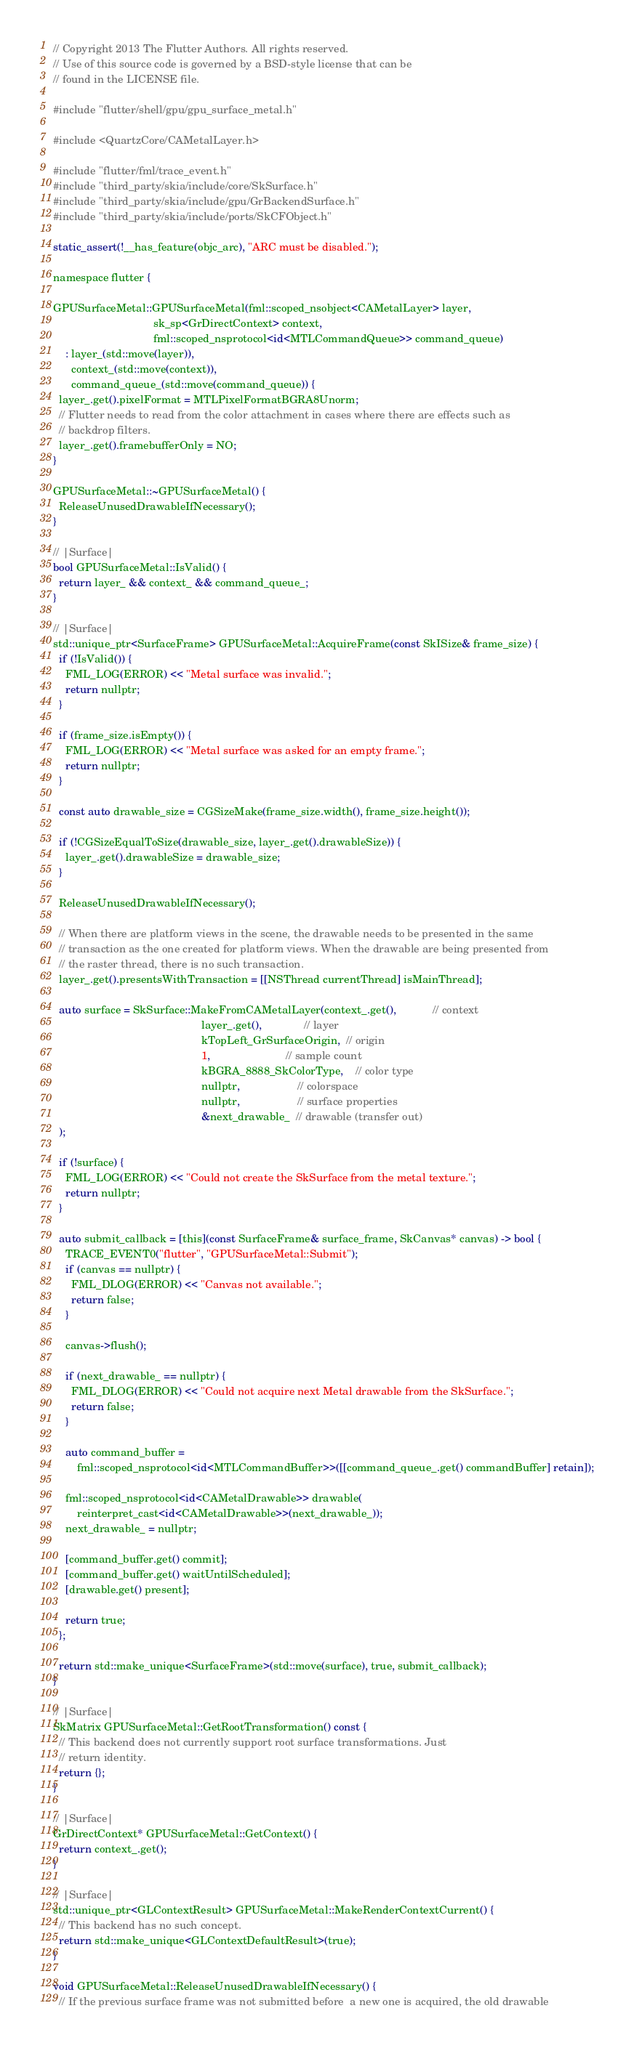Convert code to text. <code><loc_0><loc_0><loc_500><loc_500><_ObjectiveC_>// Copyright 2013 The Flutter Authors. All rights reserved.
// Use of this source code is governed by a BSD-style license that can be
// found in the LICENSE file.

#include "flutter/shell/gpu/gpu_surface_metal.h"

#include <QuartzCore/CAMetalLayer.h>

#include "flutter/fml/trace_event.h"
#include "third_party/skia/include/core/SkSurface.h"
#include "third_party/skia/include/gpu/GrBackendSurface.h"
#include "third_party/skia/include/ports/SkCFObject.h"

static_assert(!__has_feature(objc_arc), "ARC must be disabled.");

namespace flutter {

GPUSurfaceMetal::GPUSurfaceMetal(fml::scoped_nsobject<CAMetalLayer> layer,
                                 sk_sp<GrDirectContext> context,
                                 fml::scoped_nsprotocol<id<MTLCommandQueue>> command_queue)
    : layer_(std::move(layer)),
      context_(std::move(context)),
      command_queue_(std::move(command_queue)) {
  layer_.get().pixelFormat = MTLPixelFormatBGRA8Unorm;
  // Flutter needs to read from the color attachment in cases where there are effects such as
  // backdrop filters.
  layer_.get().framebufferOnly = NO;
}

GPUSurfaceMetal::~GPUSurfaceMetal() {
  ReleaseUnusedDrawableIfNecessary();
}

// |Surface|
bool GPUSurfaceMetal::IsValid() {
  return layer_ && context_ && command_queue_;
}

// |Surface|
std::unique_ptr<SurfaceFrame> GPUSurfaceMetal::AcquireFrame(const SkISize& frame_size) {
  if (!IsValid()) {
    FML_LOG(ERROR) << "Metal surface was invalid.";
    return nullptr;
  }

  if (frame_size.isEmpty()) {
    FML_LOG(ERROR) << "Metal surface was asked for an empty frame.";
    return nullptr;
  }

  const auto drawable_size = CGSizeMake(frame_size.width(), frame_size.height());

  if (!CGSizeEqualToSize(drawable_size, layer_.get().drawableSize)) {
    layer_.get().drawableSize = drawable_size;
  }

  ReleaseUnusedDrawableIfNecessary();

  // When there are platform views in the scene, the drawable needs to be presented in the same
  // transaction as the one created for platform views. When the drawable are being presented from
  // the raster thread, there is no such transaction.
  layer_.get().presentsWithTransaction = [[NSThread currentThread] isMainThread];

  auto surface = SkSurface::MakeFromCAMetalLayer(context_.get(),            // context
                                                 layer_.get(),              // layer
                                                 kTopLeft_GrSurfaceOrigin,  // origin
                                                 1,                         // sample count
                                                 kBGRA_8888_SkColorType,    // color type
                                                 nullptr,                   // colorspace
                                                 nullptr,                   // surface properties
                                                 &next_drawable_  // drawable (transfer out)
  );

  if (!surface) {
    FML_LOG(ERROR) << "Could not create the SkSurface from the metal texture.";
    return nullptr;
  }

  auto submit_callback = [this](const SurfaceFrame& surface_frame, SkCanvas* canvas) -> bool {
    TRACE_EVENT0("flutter", "GPUSurfaceMetal::Submit");
    if (canvas == nullptr) {
      FML_DLOG(ERROR) << "Canvas not available.";
      return false;
    }

    canvas->flush();

    if (next_drawable_ == nullptr) {
      FML_DLOG(ERROR) << "Could not acquire next Metal drawable from the SkSurface.";
      return false;
    }

    auto command_buffer =
        fml::scoped_nsprotocol<id<MTLCommandBuffer>>([[command_queue_.get() commandBuffer] retain]);

    fml::scoped_nsprotocol<id<CAMetalDrawable>> drawable(
        reinterpret_cast<id<CAMetalDrawable>>(next_drawable_));
    next_drawable_ = nullptr;

    [command_buffer.get() commit];
    [command_buffer.get() waitUntilScheduled];
    [drawable.get() present];

    return true;
  };

  return std::make_unique<SurfaceFrame>(std::move(surface), true, submit_callback);
}

// |Surface|
SkMatrix GPUSurfaceMetal::GetRootTransformation() const {
  // This backend does not currently support root surface transformations. Just
  // return identity.
  return {};
}

// |Surface|
GrDirectContext* GPUSurfaceMetal::GetContext() {
  return context_.get();
}

// |Surface|
std::unique_ptr<GLContextResult> GPUSurfaceMetal::MakeRenderContextCurrent() {
  // This backend has no such concept.
  return std::make_unique<GLContextDefaultResult>(true);
}

void GPUSurfaceMetal::ReleaseUnusedDrawableIfNecessary() {
  // If the previous surface frame was not submitted before  a new one is acquired, the old drawable</code> 